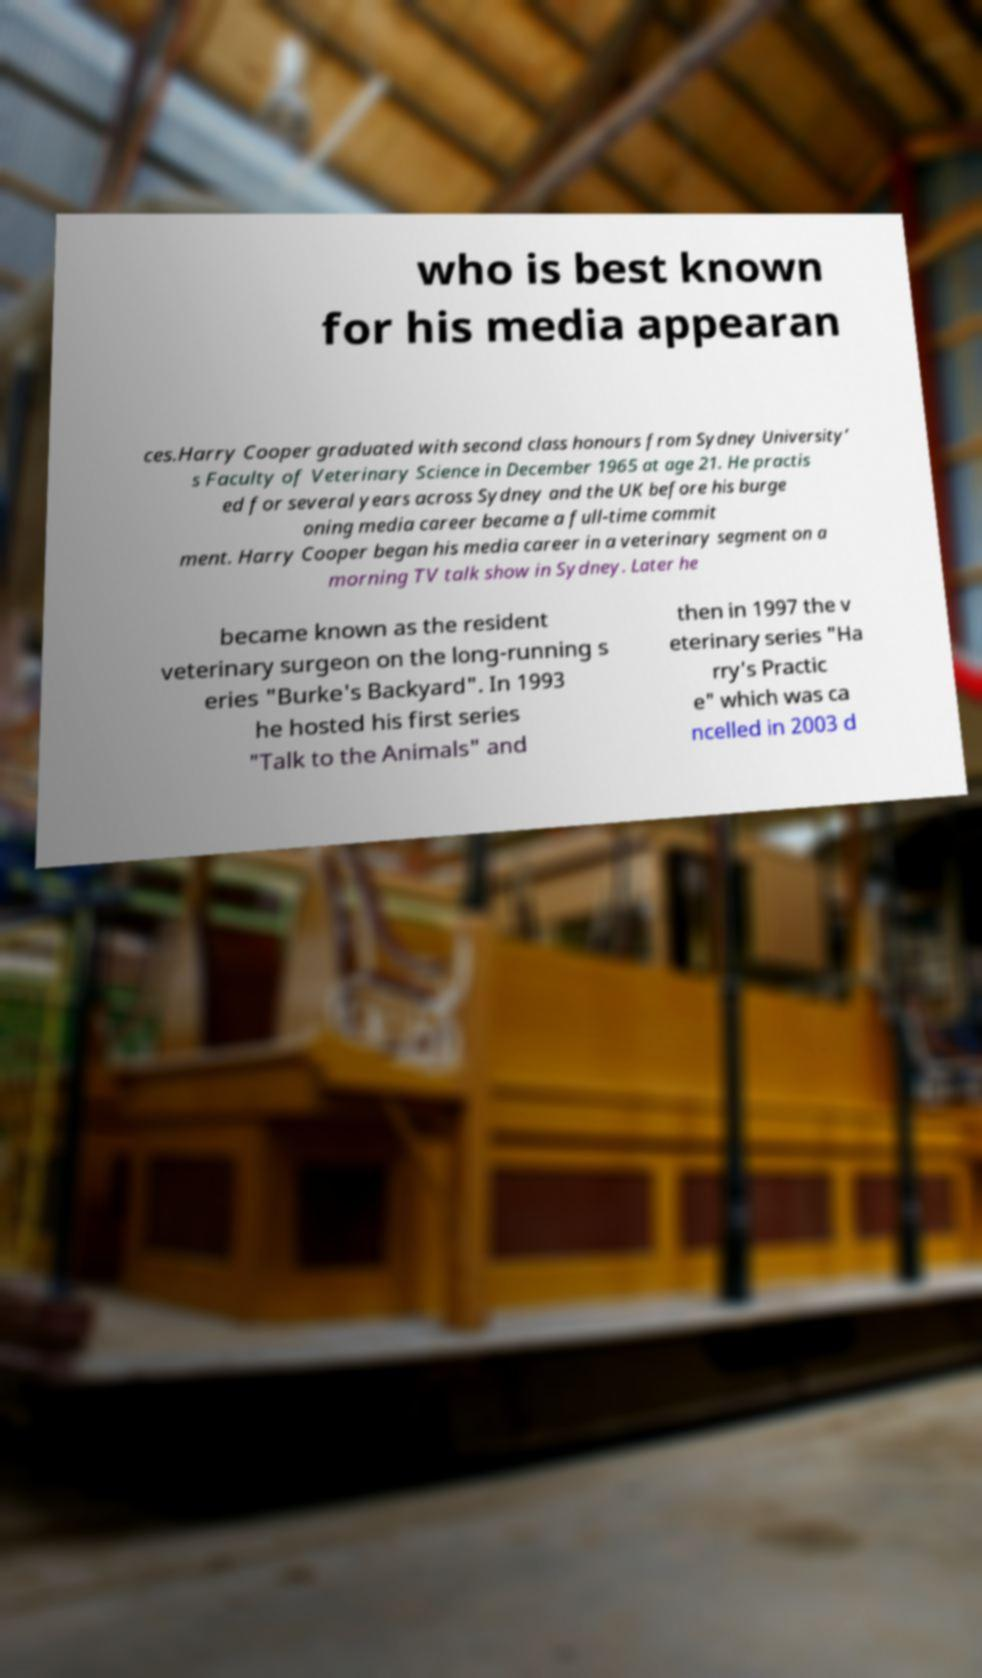Please identify and transcribe the text found in this image. who is best known for his media appearan ces.Harry Cooper graduated with second class honours from Sydney University’ s Faculty of Veterinary Science in December 1965 at age 21. He practis ed for several years across Sydney and the UK before his burge oning media career became a full-time commit ment. Harry Cooper began his media career in a veterinary segment on a morning TV talk show in Sydney. Later he became known as the resident veterinary surgeon on the long-running s eries "Burke's Backyard". In 1993 he hosted his first series "Talk to the Animals" and then in 1997 the v eterinary series "Ha rry's Practic e" which was ca ncelled in 2003 d 